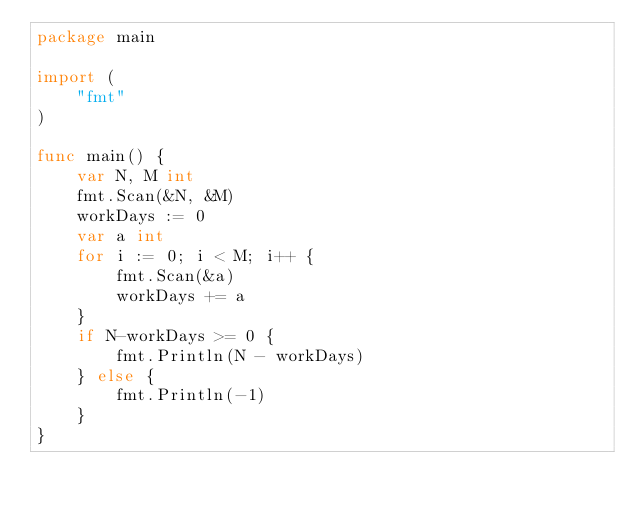<code> <loc_0><loc_0><loc_500><loc_500><_Go_>package main

import (
	"fmt"
)

func main() {
	var N, M int
	fmt.Scan(&N, &M)
	workDays := 0
	var a int
	for i := 0; i < M; i++ {
		fmt.Scan(&a)
		workDays += a
	}
	if N-workDays >= 0 {
		fmt.Println(N - workDays)
	} else {
		fmt.Println(-1)
	}
}
</code> 